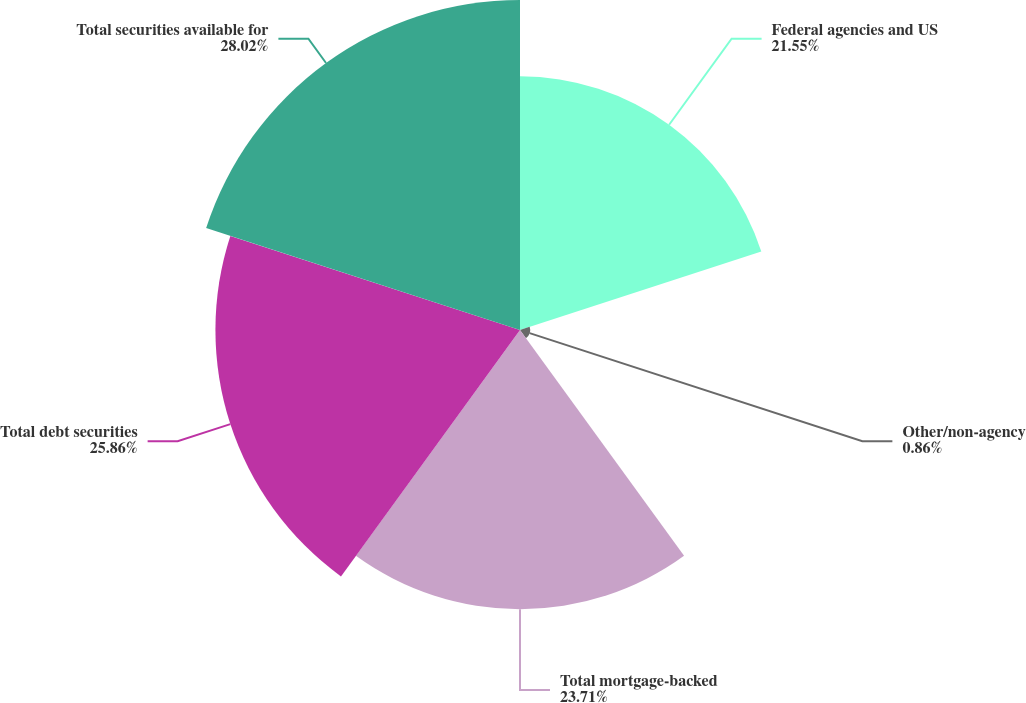<chart> <loc_0><loc_0><loc_500><loc_500><pie_chart><fcel>Federal agencies and US<fcel>Other/non-agency<fcel>Total mortgage-backed<fcel>Total debt securities<fcel>Total securities available for<nl><fcel>21.55%<fcel>0.86%<fcel>23.71%<fcel>25.87%<fcel>28.03%<nl></chart> 